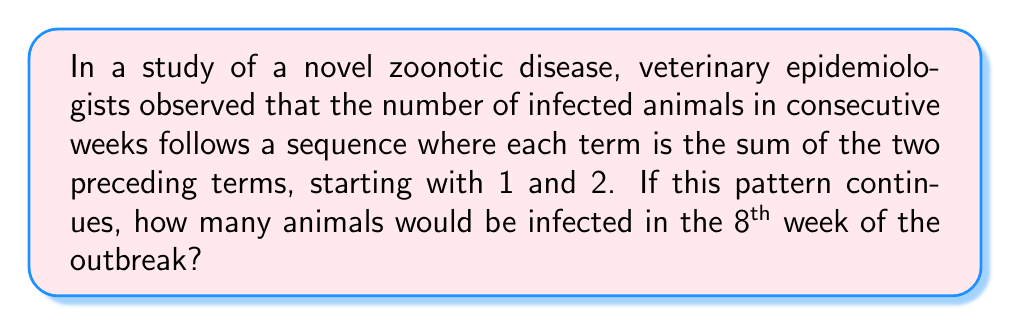What is the answer to this math problem? Let's approach this step-by-step:

1) First, we need to recognize that this sequence is the famous Fibonacci sequence, where each term is the sum of the two preceding terms. In mathematical notation:

   $F_n = F_{n-1} + F_{n-2}$

2) We're given that the sequence starts with 1 and 2. Let's write out the first few terms:

   Week 1: 1
   Week 2: 2
   Week 3: 1 + 2 = 3
   Week 4: 2 + 3 = 5
   Week 5: 3 + 5 = 8
   Week 6: 5 + 8 = 13
   Week 7: 8 + 13 = 21
   Week 8: 13 + 21 = 34

3) We can verify each step using the Fibonacci recurrence relation:

   $F_3 = F_2 + F_1 = 2 + 1 = 3$
   $F_4 = F_3 + F_2 = 3 + 2 = 5$
   $F_5 = F_4 + F_3 = 5 + 3 = 8$
   $F_6 = F_5 + F_4 = 8 + 5 = 13$
   $F_7 = F_6 + F_5 = 13 + 8 = 21$
   $F_8 = F_7 + F_6 = 21 + 13 = 34$

4) Therefore, in the 8th week of the outbreak, there would be 34 infected animals.

This Fibonacci-like growth is sometimes observed in the early stages of disease outbreaks, making it a relevant model for studying the spread of infectious diseases in animal populations.
Answer: 34 